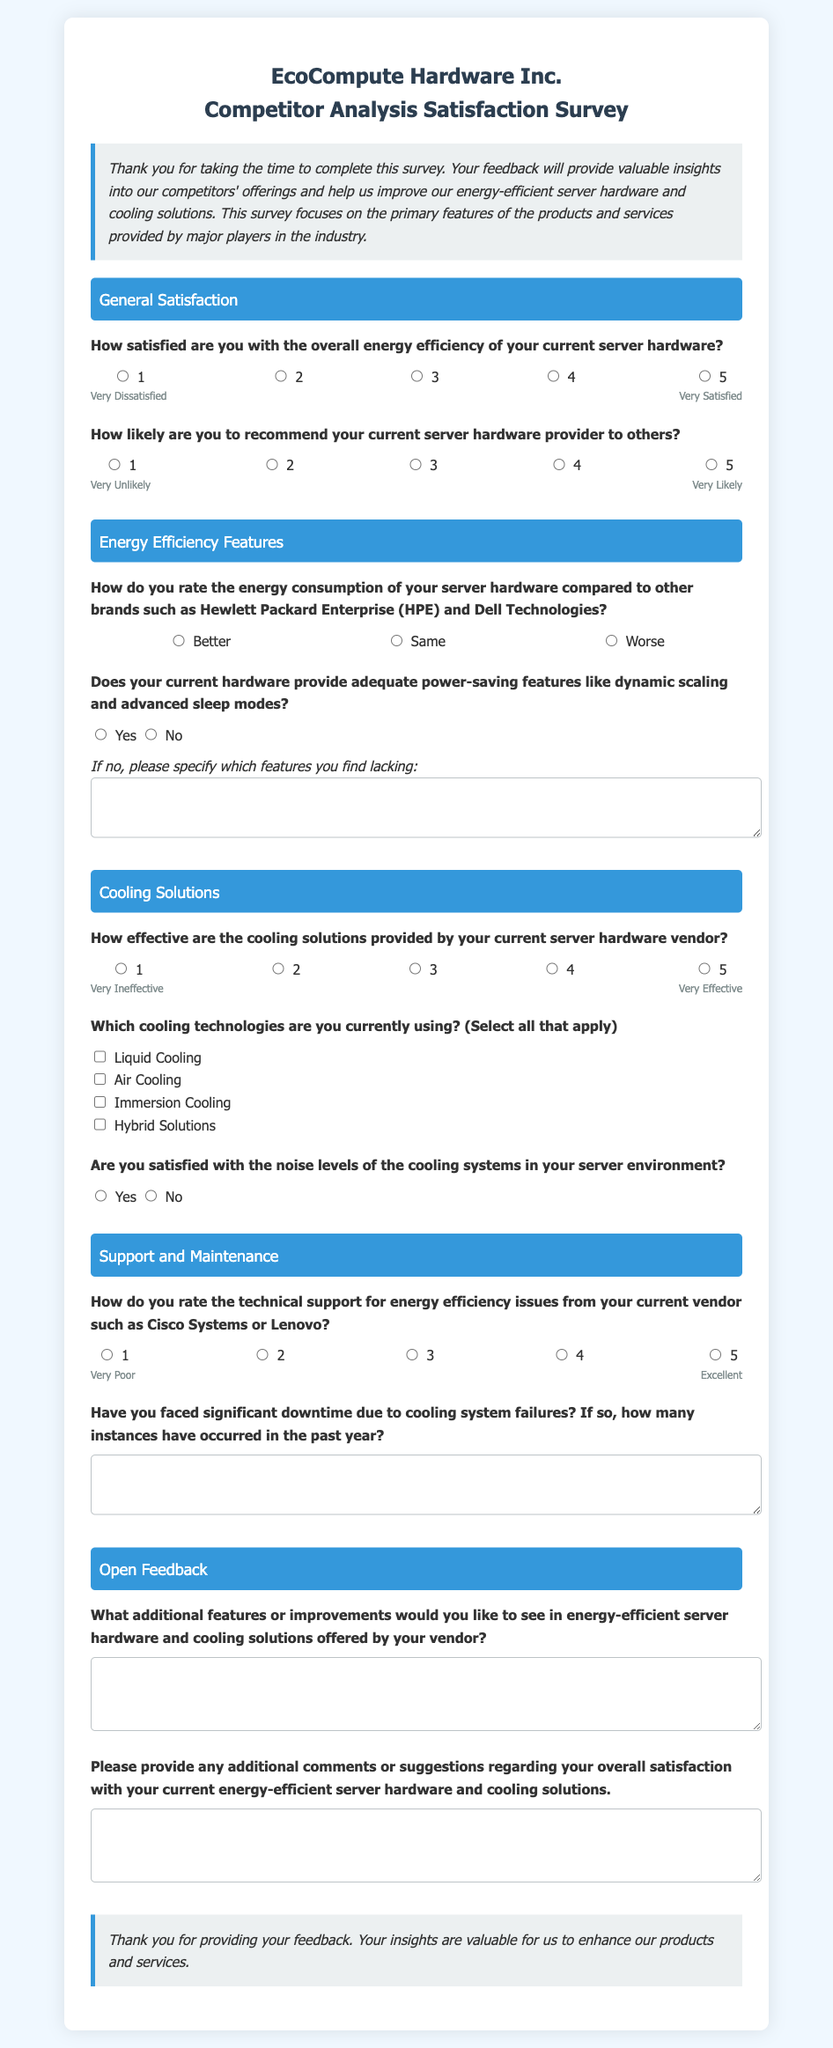What is the title of the survey? The title of the survey is displayed prominently at the top of the document: "EcoCompute Hardware Inc. - Competitor Analysis Survey".
Answer: EcoCompute Hardware Inc. - Competitor Analysis Survey What kind of feedback does the survey aim to gather? The introduction states that the survey aims to gather insights into competitors' offerings and improve energy-efficient server hardware and cooling solutions.
Answer: Insights into competitors' offerings How satisfied are respondents expected to be with their current server hardware? The survey includes a question asking respondents to rate their satisfaction on a scale from 1 to 5, indicating the level of satisfaction with overall energy efficiency.
Answer: 1 to 5 Which three brands are mentioned for comparison in the energy consumption question? The document explicitly compares energy consumption with Hewlett Packard Enterprise, Dell Technologies, and suggests other competitors indirectly.
Answer: Hewlett Packard Enterprise, Dell Technologies How do respondents rate the effectiveness of their current cooling solutions? The survey provides a rating scale from 1 to 5 for respondents to assess the effectiveness of cooling solutions provided by their current vendor.
Answer: 1 to 5 What feature is specifically mentioned as an example of power-saving in the hardware? Dynamic scaling is noted as an example of a power-saving feature in the question asking if the current hardware provides adequate power-saving features.
Answer: Dynamic scaling How many cooling technology options are listed for selection? The survey offers four specific cooling technology options for respondents to select from, including Liquid Cooling, Air Cooling, Immersion Cooling, and Hybrid Solutions.
Answer: Four What is the final section of the survey called? The last section of the document is labeled "Open Feedback".
Answer: Open Feedback How do respondents indicate the number of downtime instances due to cooling system failures? Respondents provide answers in a text area provided for one question regarding significant downtime instances related to cooling failures in the past year.
Answer: Text area What type of feedback does the closing section express gratitude for? The closing section thanks respondents for providing their feedback about overall satisfaction with energy-efficient server hardware and cooling solutions.
Answer: Overall satisfaction 